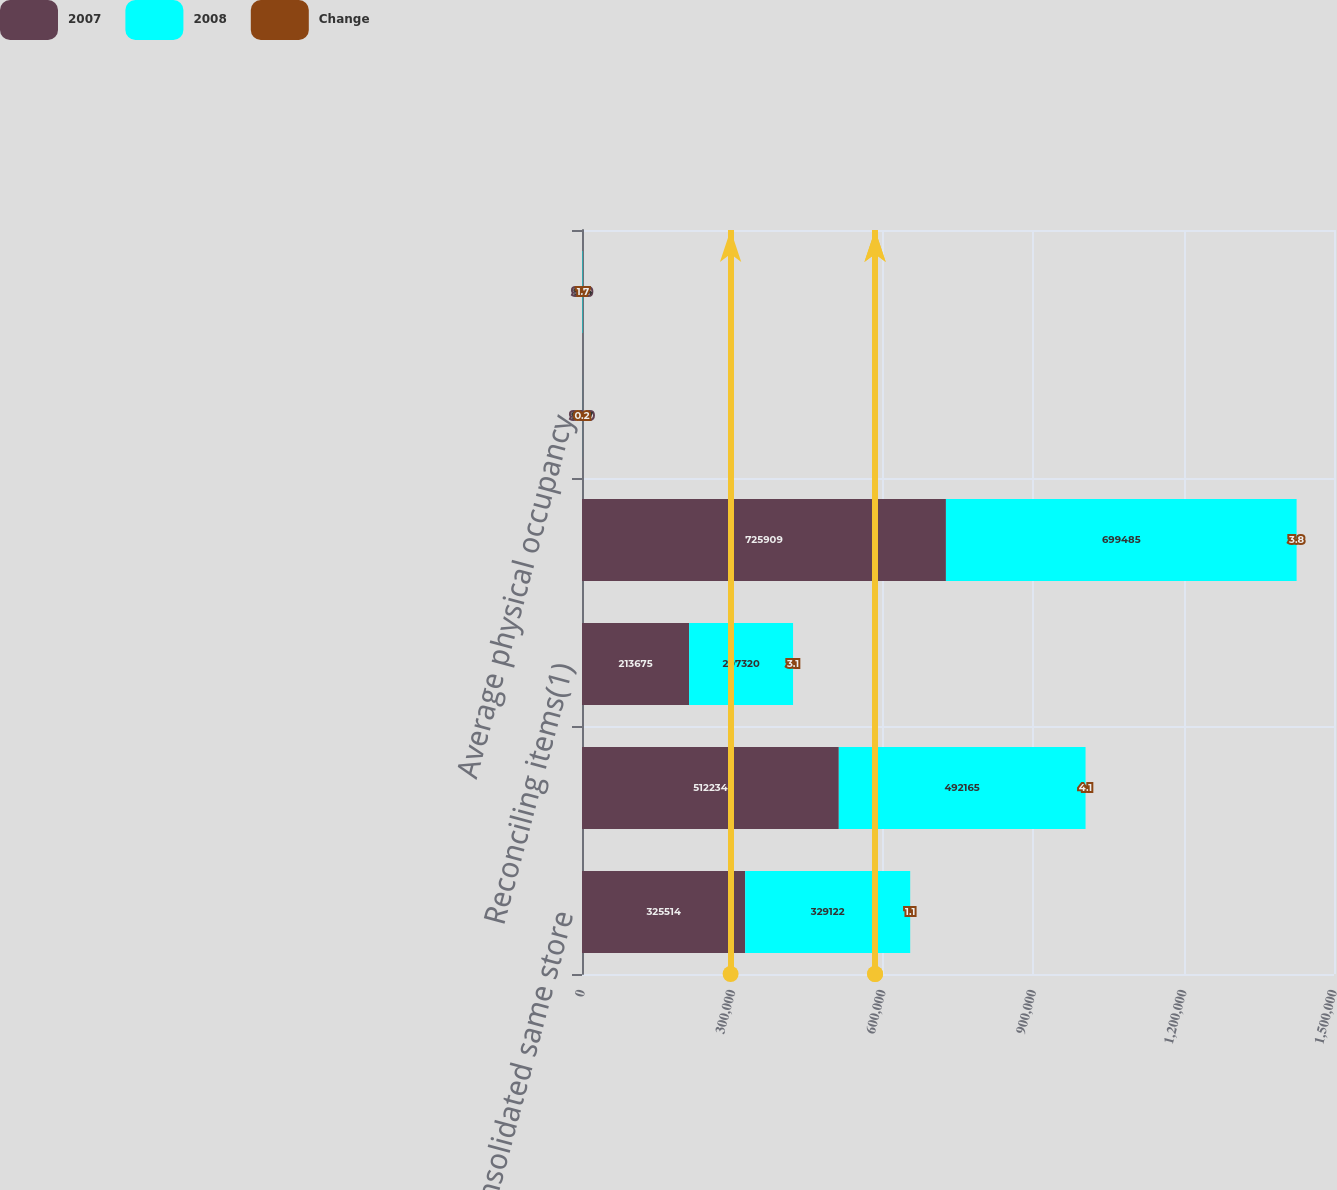Convert chart to OTSL. <chart><loc_0><loc_0><loc_500><loc_500><stacked_bar_chart><ecel><fcel>Consolidated same store<fcel>Same store net operating<fcel>Reconciling items(1)<fcel>Real estate segment net<fcel>Average physical occupancy<fcel>Average rent/unit/month<nl><fcel>2007<fcel>325514<fcel>512234<fcel>213675<fcel>725909<fcel>94.9<fcel>970<nl><fcel>2008<fcel>329122<fcel>492165<fcel>207320<fcel>699485<fcel>94.7<fcel>954<nl><fcel>Change<fcel>1.1<fcel>4.1<fcel>3.1<fcel>3.8<fcel>0.2<fcel>1.7<nl></chart> 